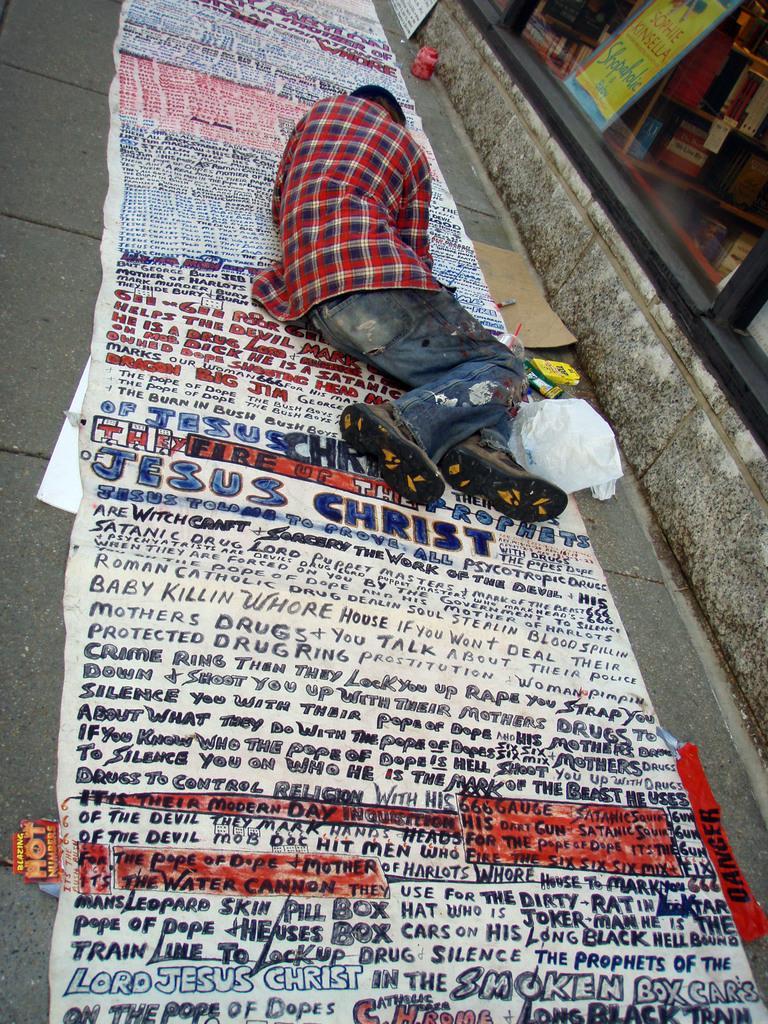In one or two sentences, can you explain what this image depicts? In this image, we can see the ground with some objects. We can also see a poster with some text and a person is lying on it. We can see the wall and some glass on the right. We can see some shelves with objects. We can also see a board with some text. 